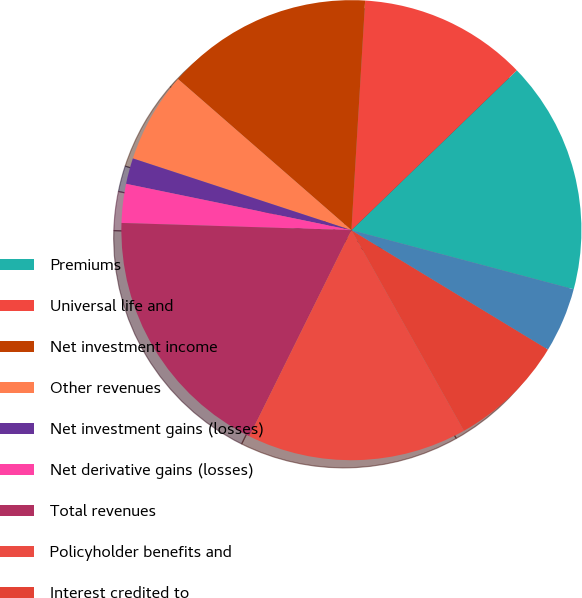<chart> <loc_0><loc_0><loc_500><loc_500><pie_chart><fcel>Premiums<fcel>Universal life and<fcel>Net investment income<fcel>Other revenues<fcel>Net investment gains (losses)<fcel>Net derivative gains (losses)<fcel>Total revenues<fcel>Policyholder benefits and<fcel>Interest credited to<fcel>Policyholder dividends<nl><fcel>16.36%<fcel>11.82%<fcel>14.54%<fcel>6.36%<fcel>1.82%<fcel>2.73%<fcel>18.18%<fcel>15.45%<fcel>8.18%<fcel>4.55%<nl></chart> 